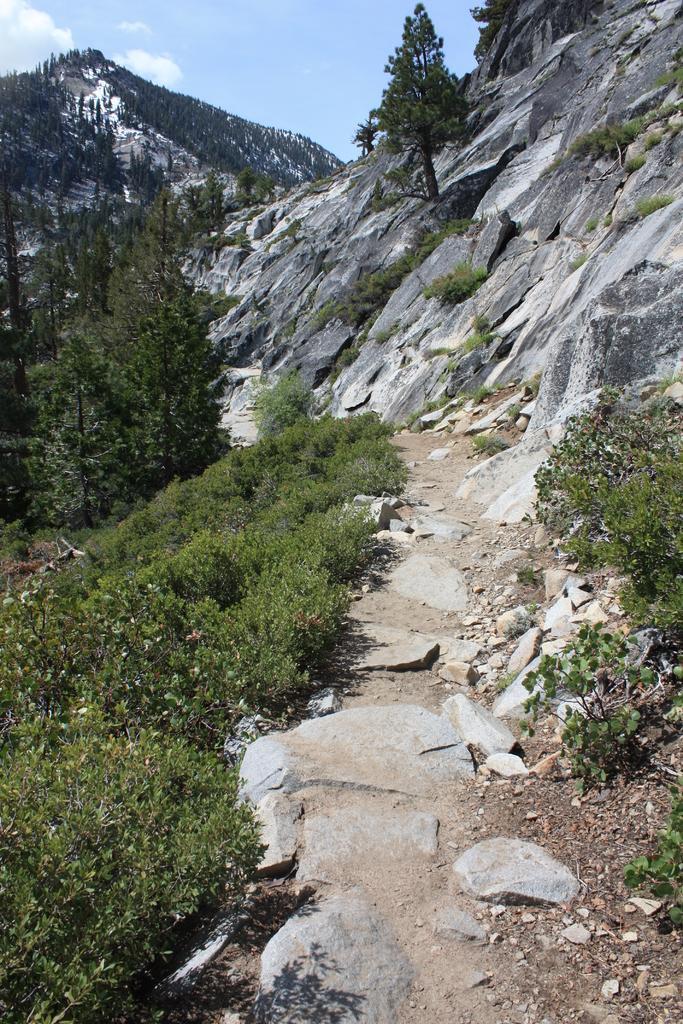Please provide a concise description of this image. As we can see in the image there are trees, hills, grass and sky. 